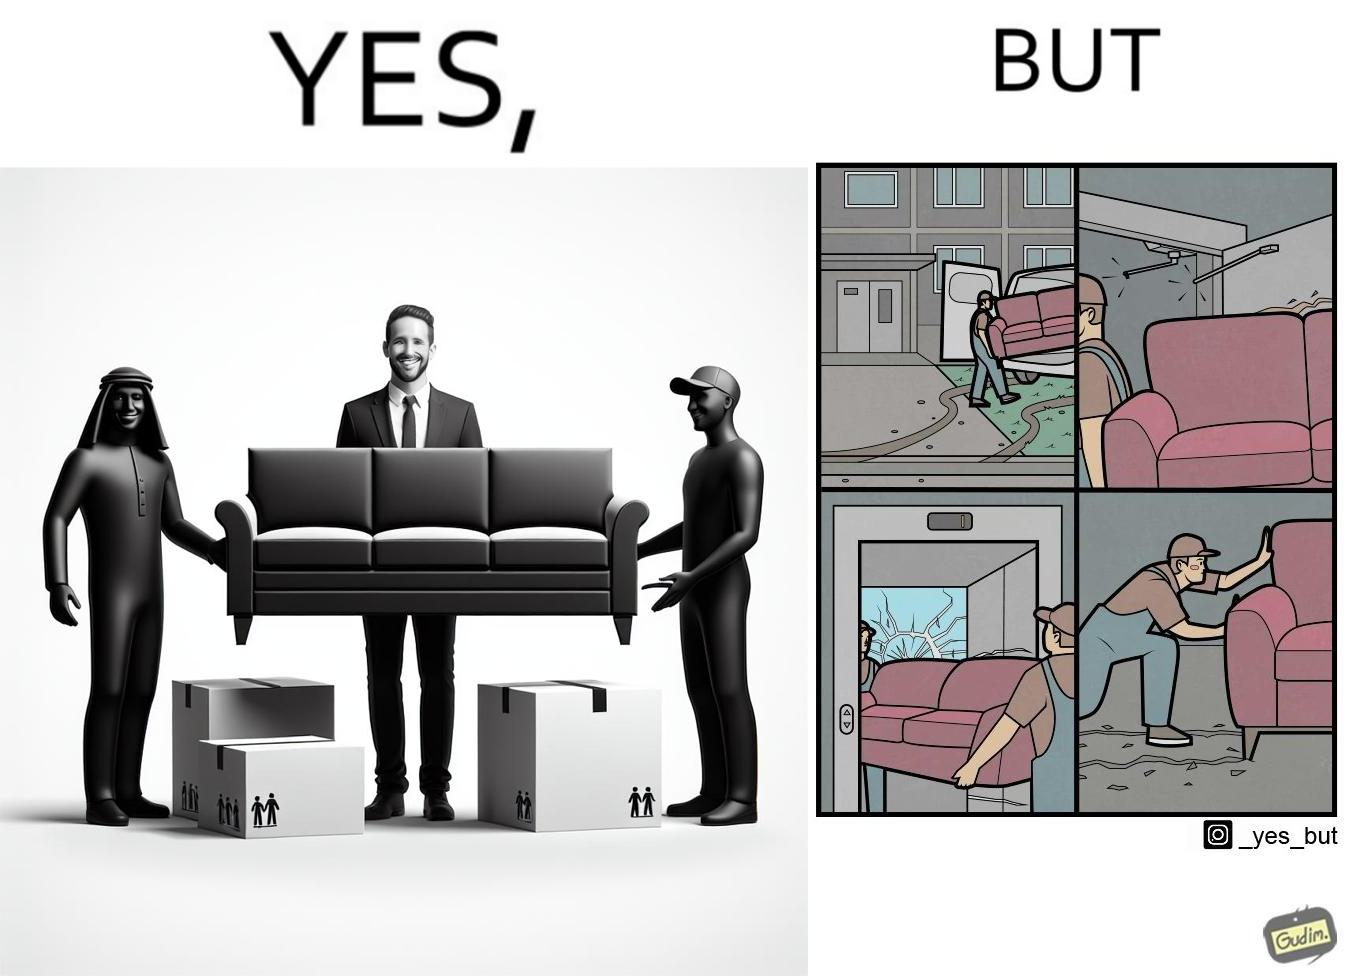What does this image depict? The images are funny since they show how even though the hired movers achieve their task of moving in furniture, in the process, the cause damage to the whole house 